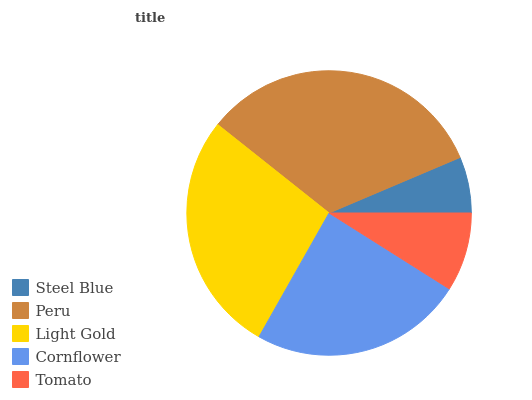Is Steel Blue the minimum?
Answer yes or no. Yes. Is Peru the maximum?
Answer yes or no. Yes. Is Light Gold the minimum?
Answer yes or no. No. Is Light Gold the maximum?
Answer yes or no. No. Is Peru greater than Light Gold?
Answer yes or no. Yes. Is Light Gold less than Peru?
Answer yes or no. Yes. Is Light Gold greater than Peru?
Answer yes or no. No. Is Peru less than Light Gold?
Answer yes or no. No. Is Cornflower the high median?
Answer yes or no. Yes. Is Cornflower the low median?
Answer yes or no. Yes. Is Peru the high median?
Answer yes or no. No. Is Steel Blue the low median?
Answer yes or no. No. 